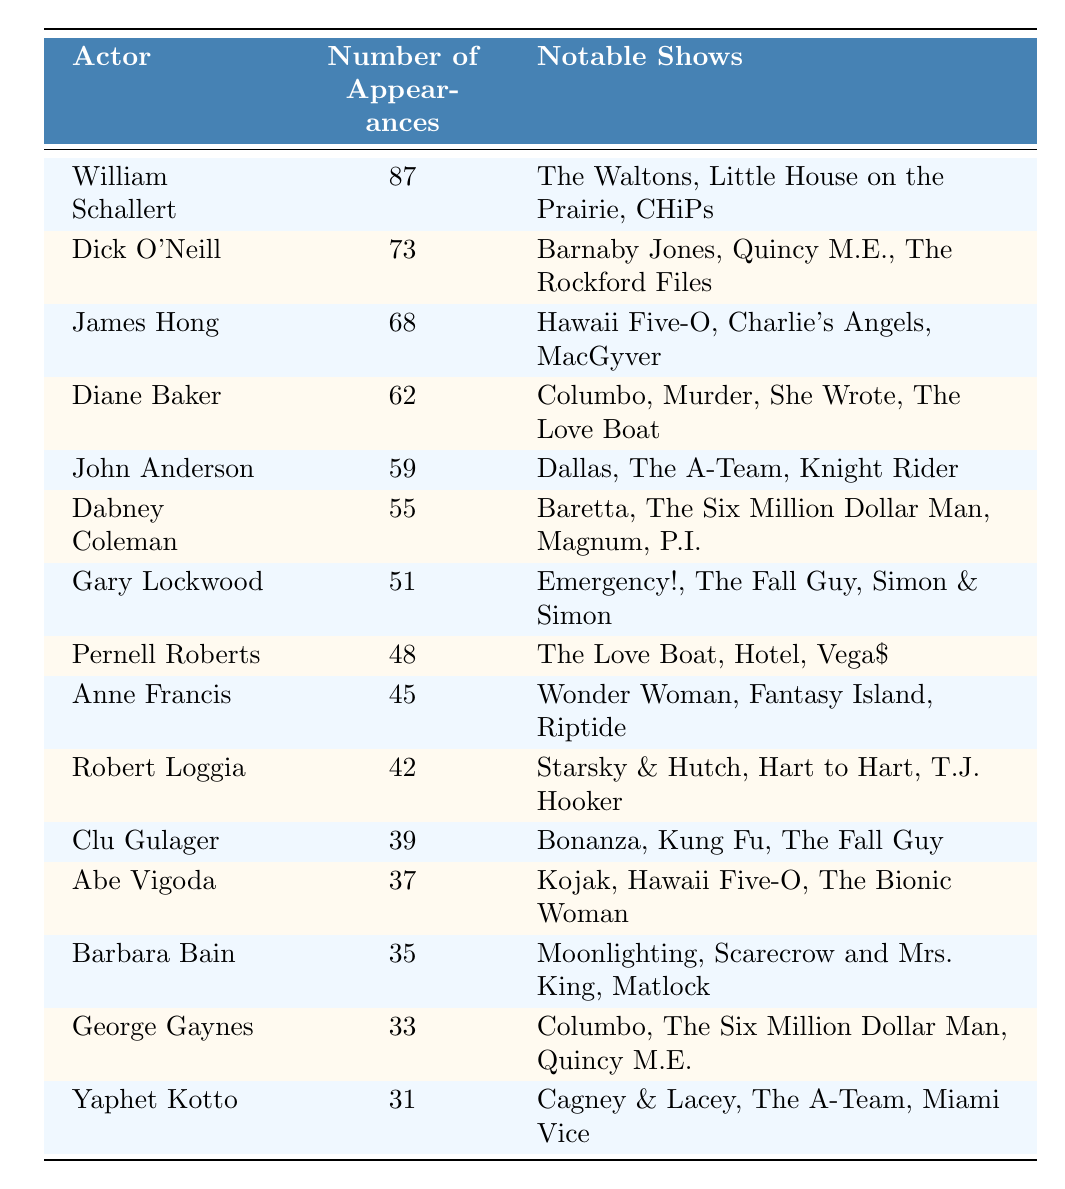What actor has the most appearances in 70s and 80s TV dramas? William Schallert has the highest number of appearances listed in the table, with a total of 87.
Answer: William Schallert How many appearances did Dick O'Neill make? The table states that Dick O'Neill made 73 appearances across various shows.
Answer: 73 Which actor appeared in the most shows after William Schallert? The next highest number of appearances after William Schallert is from Dick O'Neill, who has 73 appearances.
Answer: Dick O'Neill What is the total number of appearances by the top three actors? Adding the appearances of William Schallert (87), Dick O'Neill (73), and James Hong (68) gives 87 + 73 + 68 = 228.
Answer: 228 Is James Hong's total number of appearances greater than 70? James Hong has 68 appearances, which is less than 70, so the statement is false.
Answer: No Which two actors have the same number of appearances? The table shows that Anne Francis (45) and Robert Loggia (42) have different appearances, but no two actors share the same count.
Answer: None What is the average number of appearances for the group of actors listed in the table? There are 15 actors listed; summing all appearances (87 + 73 + 68 + 62 + 59 + 55 + 51 + 48 + 45 + 42 + 39 + 37 + 35 + 33 + 31 = 719) and dividing by 15 gives 719/15 = 47.93.
Answer: 47.93 Did any of the actors appear in "The Love Boat"? According to the table, both Diane Baker and Pernell Roberts are noted to have appeared in "The Love Boat."
Answer: Yes What percentage of appearances did Yaphet Kotto contribute to the total appearances? Yaphet Kotto had 31 appearances out of 719 total appearances. Calculating gives (31/719) * 100 = 4.31%.
Answer: 4.31% Who had more appearances, Barbara Bain or Clu Gulager? Barbara Bain has 35 appearances while Clu Gulager has 39. Since 39 is greater than 35, Clu Gulager had more.
Answer: Clu Gulager 